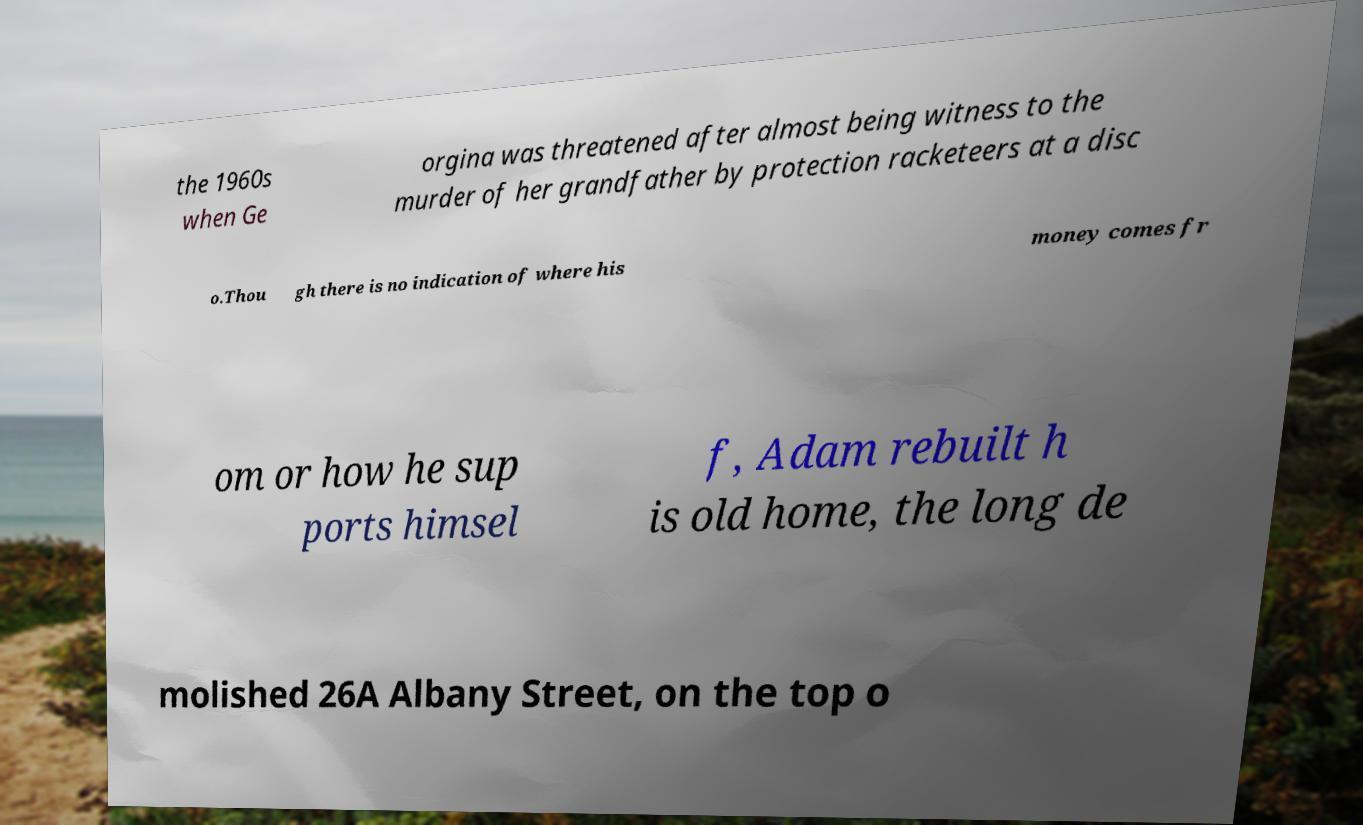I need the written content from this picture converted into text. Can you do that? the 1960s when Ge orgina was threatened after almost being witness to the murder of her grandfather by protection racketeers at a disc o.Thou gh there is no indication of where his money comes fr om or how he sup ports himsel f, Adam rebuilt h is old home, the long de molished 26A Albany Street, on the top o 